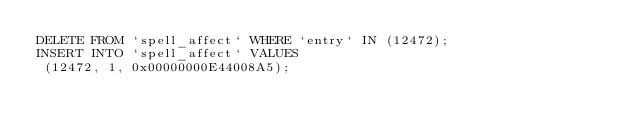<code> <loc_0><loc_0><loc_500><loc_500><_SQL_>DELETE FROM `spell_affect` WHERE `entry` IN (12472);
INSERT INTO `spell_affect` VALUES
 (12472, 1, 0x00000000E44008A5);
</code> 